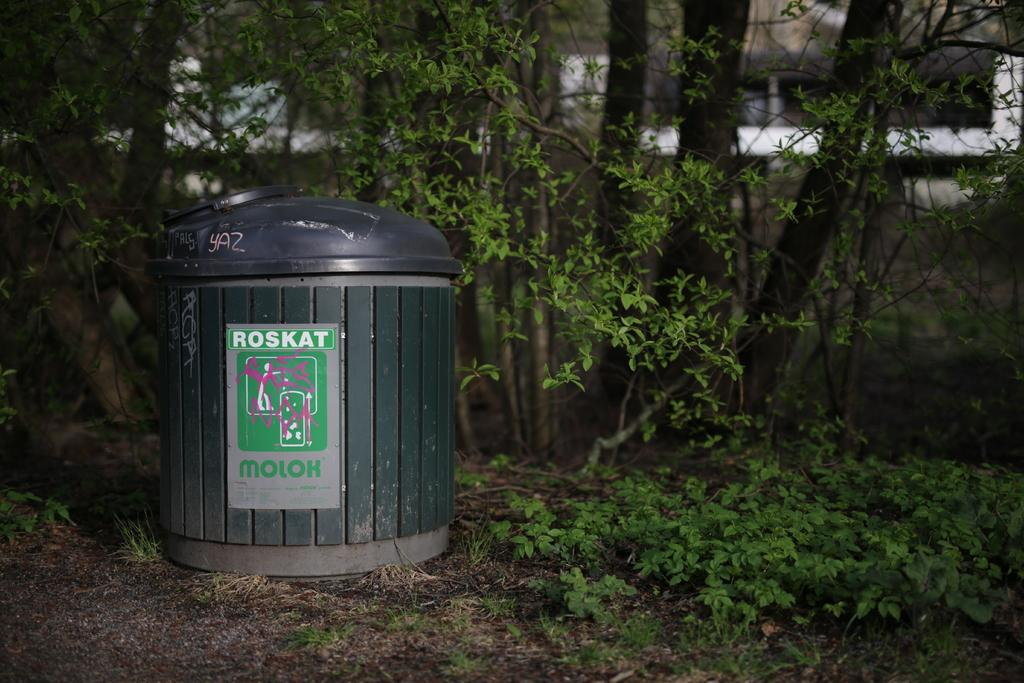<image>
Provide a brief description of the given image. A trash can has a has the words Roskat Molox on a label attached to it. 